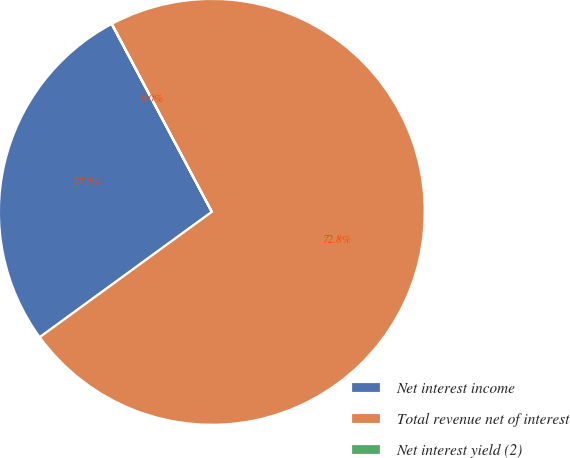Convert chart to OTSL. <chart><loc_0><loc_0><loc_500><loc_500><pie_chart><fcel>Net interest income<fcel>Total revenue net of interest<fcel>Net interest yield (2)<nl><fcel>27.23%<fcel>72.77%<fcel>0.01%<nl></chart> 